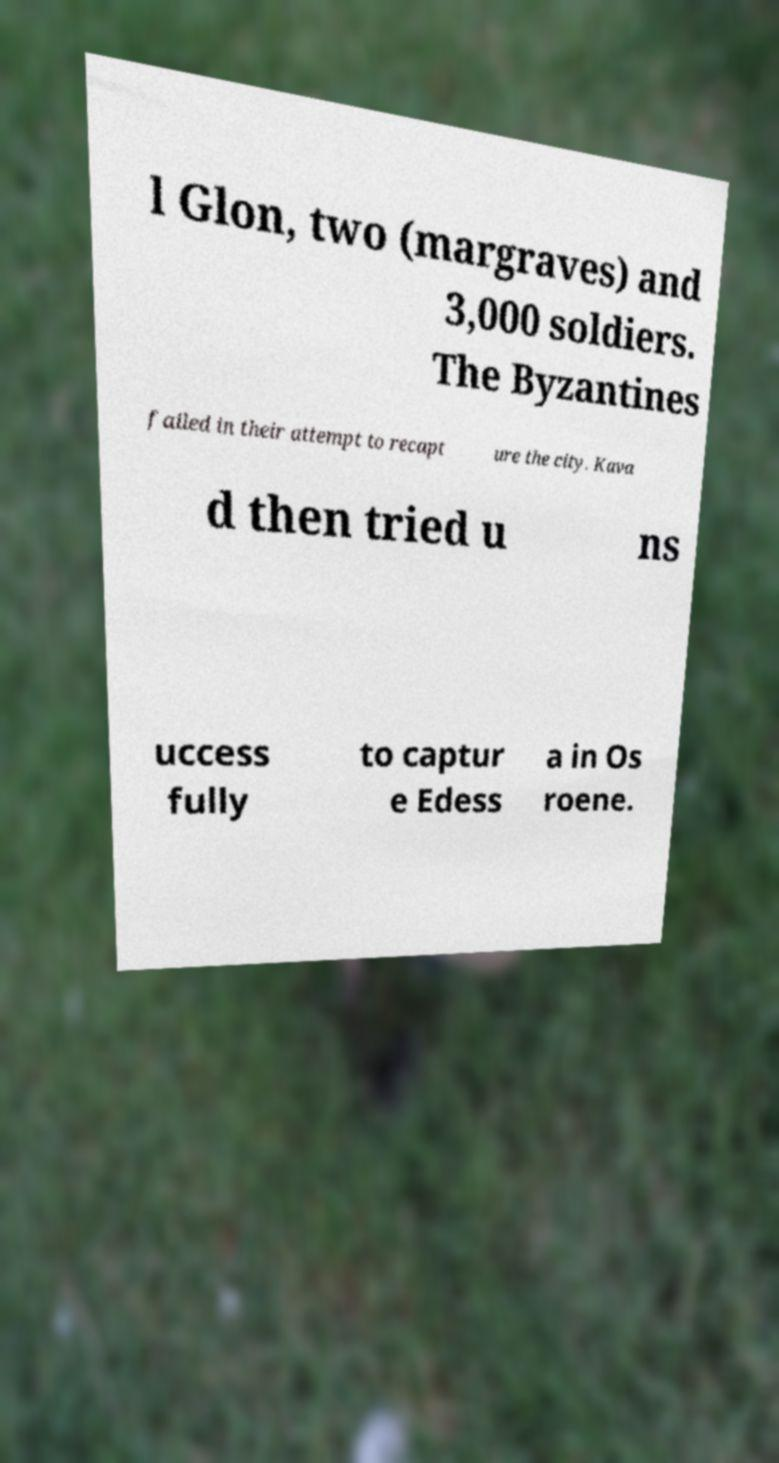Please identify and transcribe the text found in this image. l Glon, two (margraves) and 3,000 soldiers. The Byzantines failed in their attempt to recapt ure the city. Kava d then tried u ns uccess fully to captur e Edess a in Os roene. 